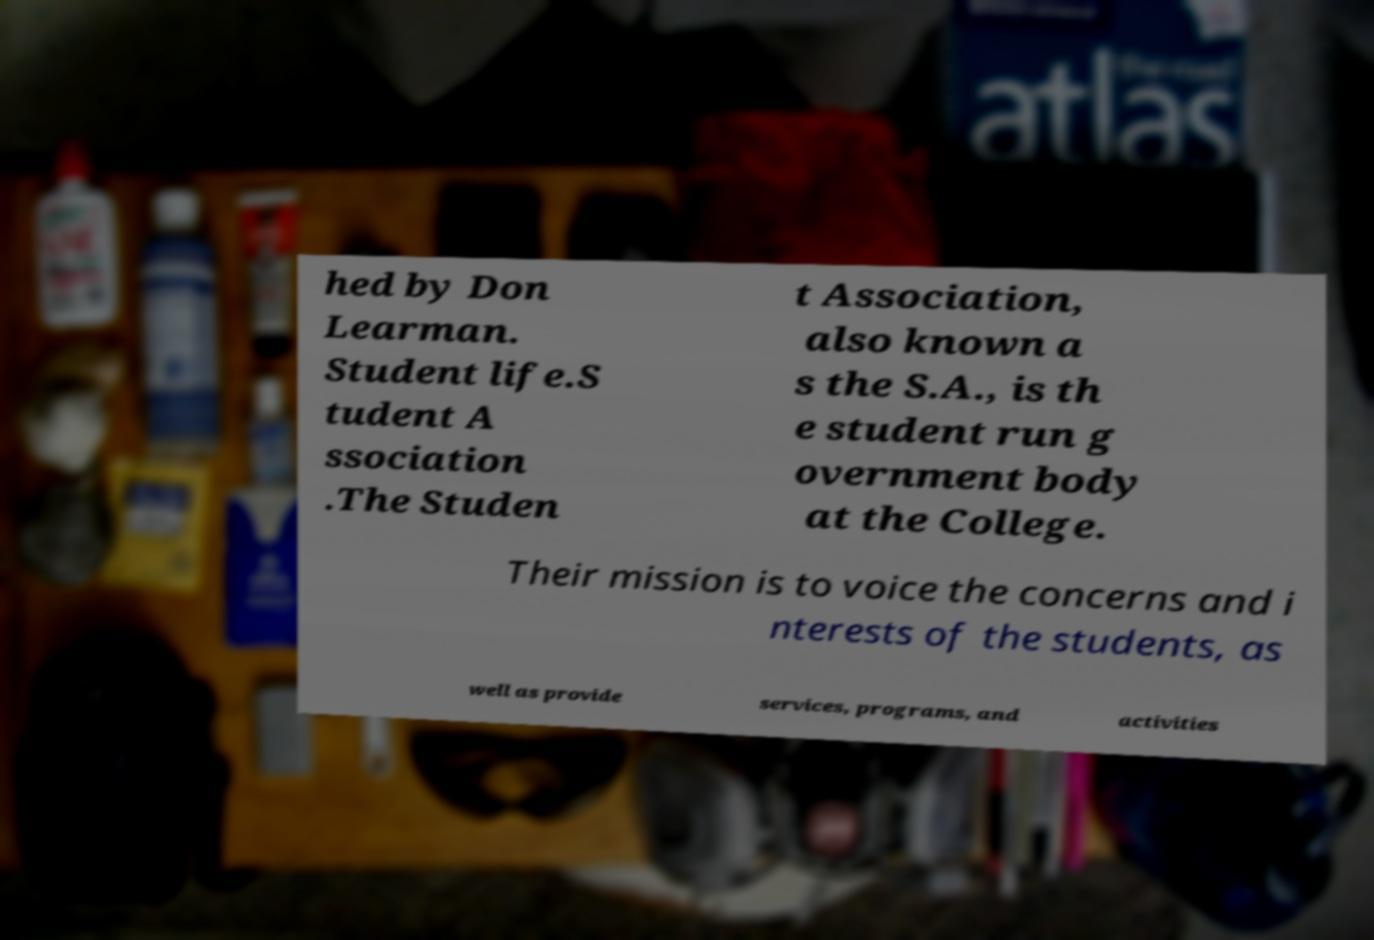What messages or text are displayed in this image? I need them in a readable, typed format. hed by Don Learman. Student life.S tudent A ssociation .The Studen t Association, also known a s the S.A., is th e student run g overnment body at the College. Their mission is to voice the concerns and i nterests of the students, as well as provide services, programs, and activities 